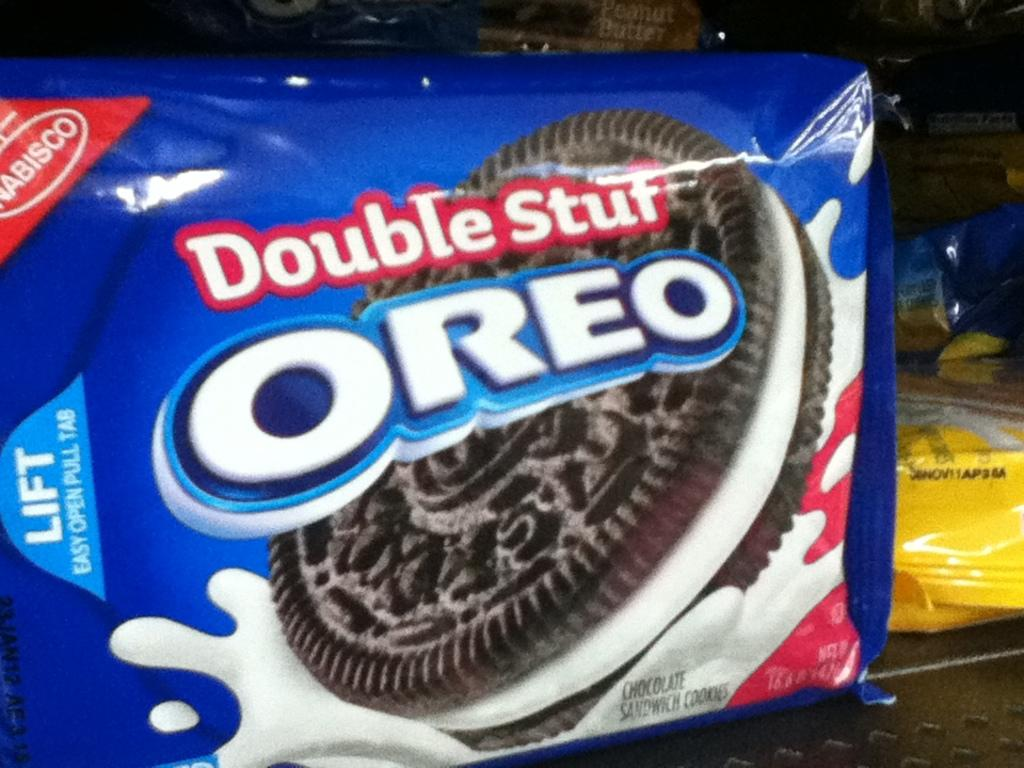What type of biscuits are visible in the image? There are two Oreo biscuit packets in the image. Can you describe any other objects on the surface in the image? Unfortunately, the provided facts do not give any information about other objects on the surface in the image. How many women are present in the image? There is no information about women in the image, as the provided facts only mention two Oreo biscuit packets and other objects on the surface. 